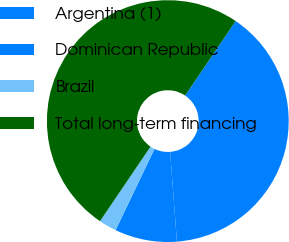Convert chart to OTSL. <chart><loc_0><loc_0><loc_500><loc_500><pie_chart><fcel>Argentina (1)<fcel>Dominican Republic<fcel>Brazil<fcel>Total long-term financing<nl><fcel>39.32%<fcel>8.31%<fcel>2.37%<fcel>50.0%<nl></chart> 